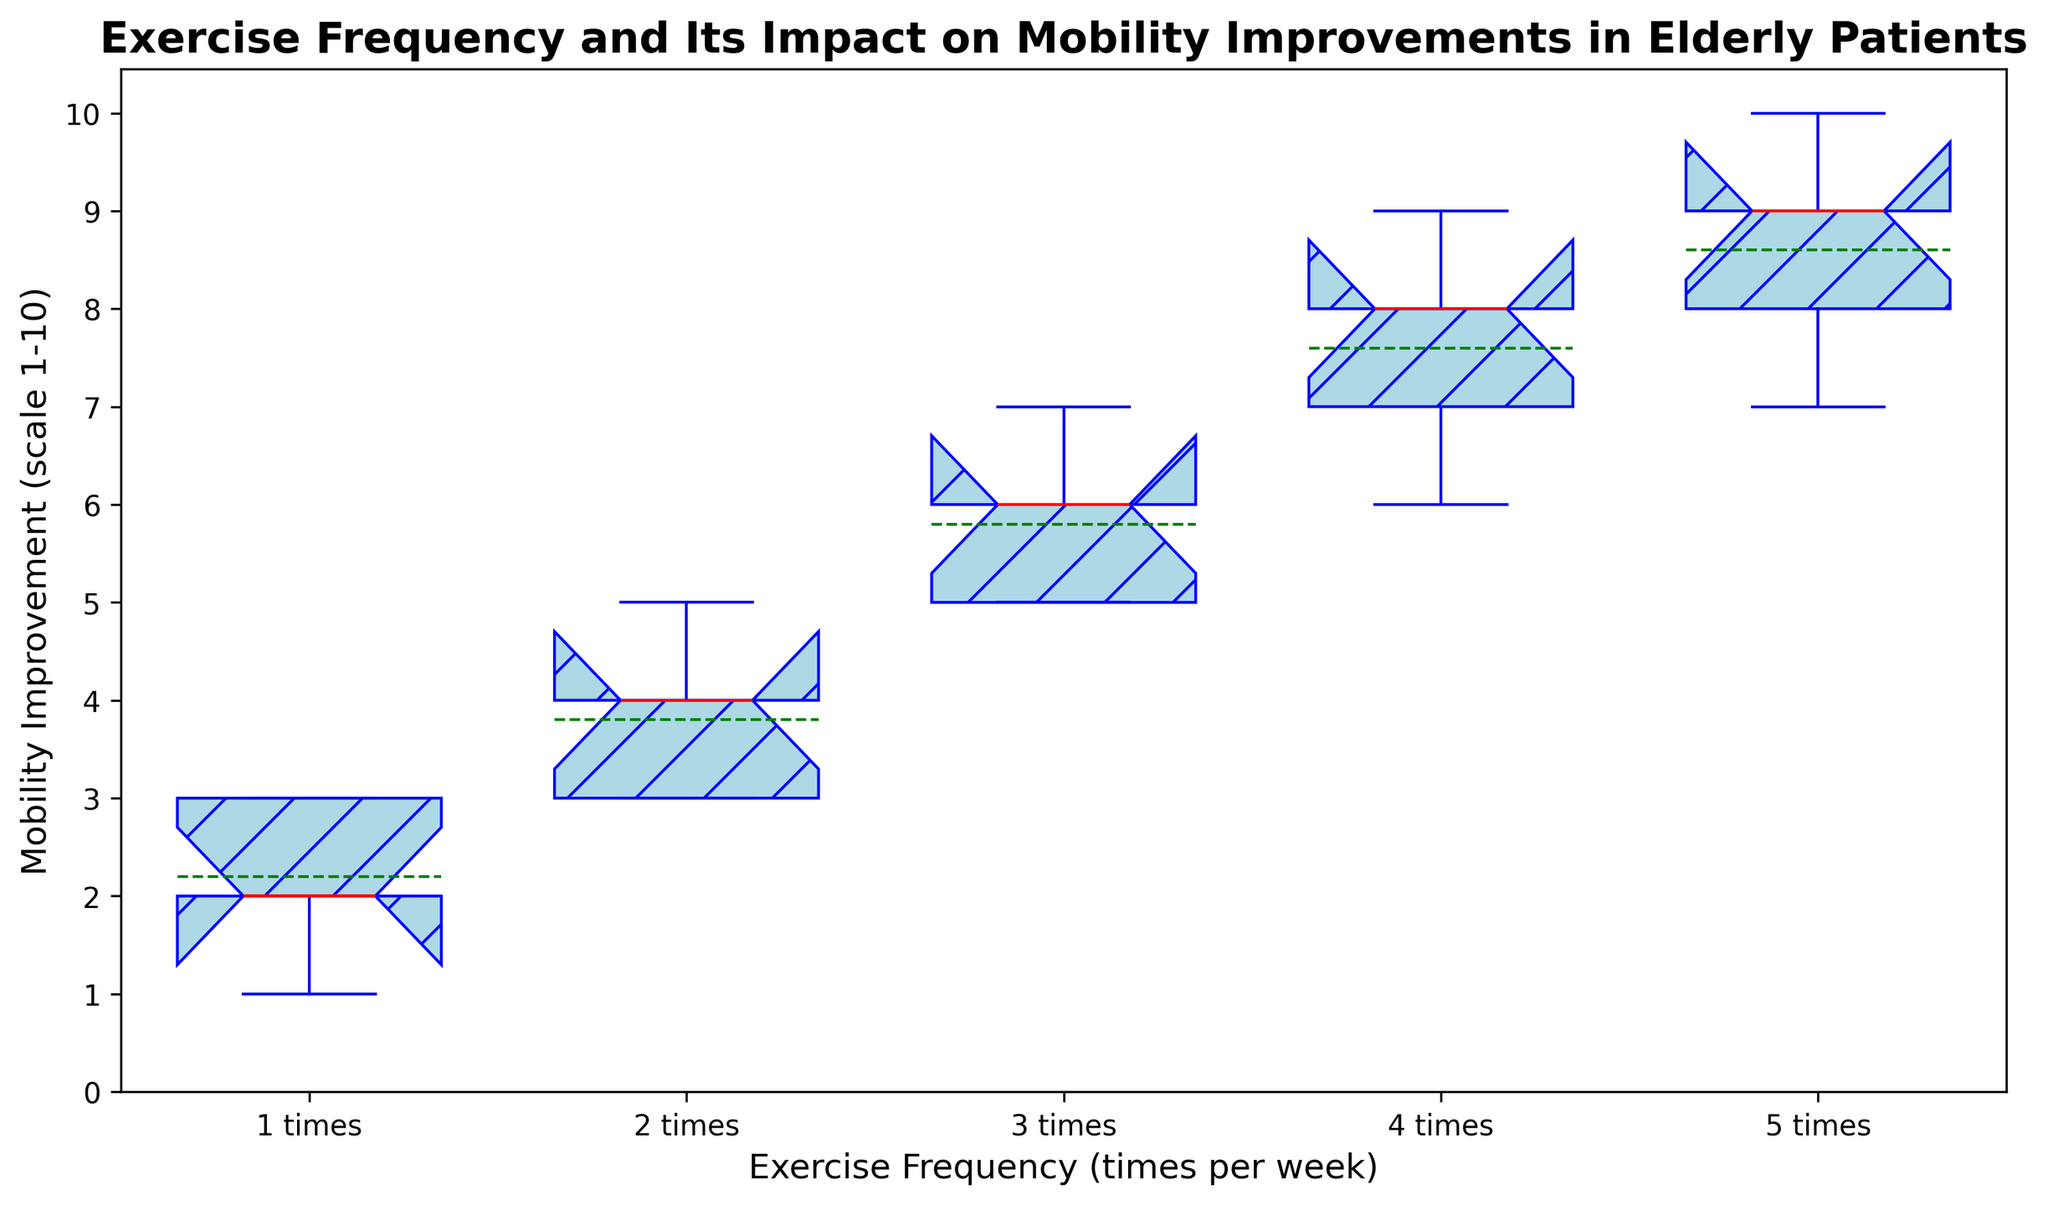What's the range of mobility improvements for the group that exercises 3 times per week? To find the range, you look at the highest and lowest values of mobility improvement for the group. The group exercising 3 times per week has a minimum value of 5 and a maximum value of 7. So, the range is 7 - 5.
Answer: 2 Which group has the highest median mobility improvement? The median is indicated by the red line in each boxplot. By inspecting the red lines, it is clear that the group exercising 5 times per week has the highest median.
Answer: Group 5 Is there any group whose mean mobility improvement is higher than the median mobility improvement of Group 4? The median mobility improvement of Group 4 is indicated by the red line, and it's 8. The mean values are shown with green lines. None of the groups has a mean value higher than 8.
Answer: No Among the groups that exercise 2 and 3 times per week, which one has a wider interquartile range (IQR)? The IQR is the range between the first quartile (bottom of the box) and the third quartile (top of the box). The box width for the group exercising 3 times per week is wider than that of the 2 times per week group.
Answer: Group 3 What is the approximate mean mobility improvement for the group exercising 4 times per week? The mean of a group is shown by the green line within the box in each boxplot. For the group exercising 4 times per week, the green line appears at 7.6.
Answer: 7.6 Compare the range of mobility improvements between the groups that exercise 2 times per week and 5 times per week. The group that exercises 2 times per week has a range from 3 to 5, so the range is 5 - 3 = 2. The group exercising 5 times per week has a range from 7 to 10, so the range is 10 - 7 = 3.
Answer: Range of Group 2: 2, Range of Group 5: 3 Identify both the groups that show the lowest and highest minimum mobility improvements. The minimum mobility improvement is the lowest point of the whisker in each boxplot. The lowest minimum value is for Group 1 at 1, while the highest minimum value is for Group 5 at 7.
Answer: Group 1 and Group 5 Which group shows the highest variability in mobility improvement? Variability can be assessed through the spread and range of the boxplot. The group exercising 4 times per week has the largest spread and range, indicating the highest variability.
Answer: Group 4 What is the interquartile range for the group exercising 1 time per week? The interquartile range (IQR) is the distance between the first and third quartiles. For the group exercising 1 time per week, it goes from 2 to 3 (top of the box is 3 and the bottom is 2). Therefore, the IQR is 3 - 2.
Answer: 1 